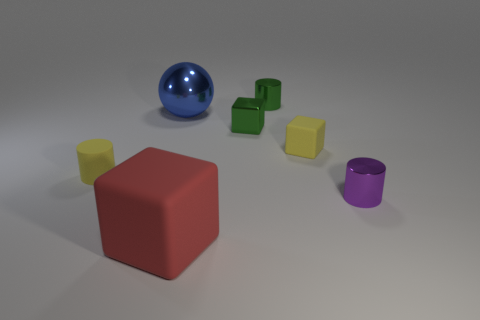What shape is the metallic object that is the same color as the shiny block?
Your response must be concise. Cylinder. Do the yellow object on the left side of the red cube and the purple cylinder have the same size?
Give a very brief answer. Yes. There is a small rubber object that is on the left side of the large red thing; is its shape the same as the big blue shiny object?
Your response must be concise. No. What number of objects are small rubber spheres or small purple things that are in front of the green cube?
Offer a terse response. 1. Is the number of small green metallic objects less than the number of cyan cubes?
Keep it short and to the point. No. Are there more big yellow blocks than big red rubber things?
Offer a very short reply. No. How many other things are the same material as the blue thing?
Provide a succinct answer. 3. There is a rubber object that is on the left side of the thing that is in front of the small purple shiny cylinder; what number of tiny yellow matte objects are behind it?
Your response must be concise. 1. How many metal objects are blue objects or small cylinders?
Make the answer very short. 3. There is a green shiny object that is to the left of the small cylinder behind the big shiny sphere; how big is it?
Offer a very short reply. Small. 